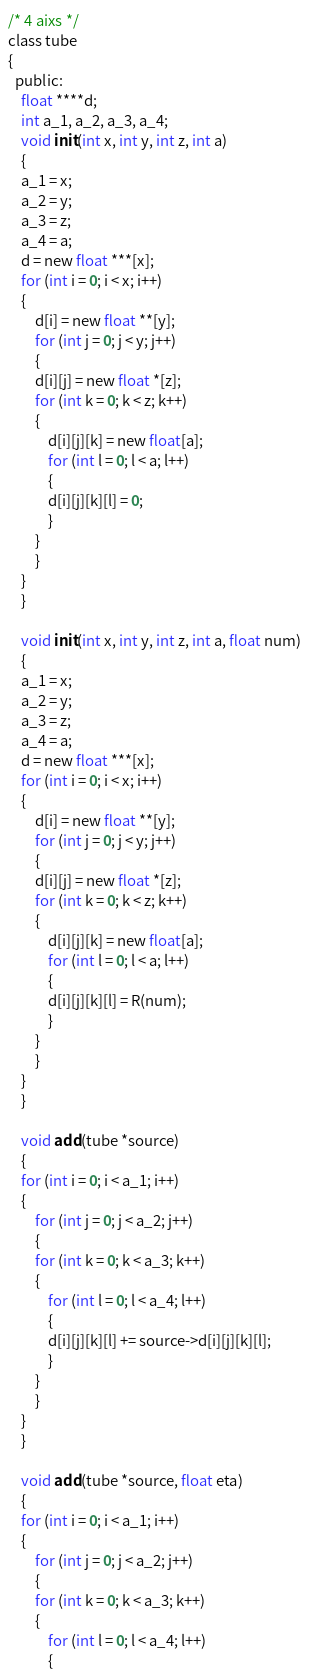<code> <loc_0><loc_0><loc_500><loc_500><_C_>/* 4 aixs */
class tube
{
  public:
    float ****d;
    int a_1, a_2, a_3, a_4;
    void init(int x, int y, int z, int a)
    {
	a_1 = x;
	a_2 = y;
	a_3 = z;
	a_4 = a;
	d = new float ***[x];
	for (int i = 0; i < x; i++)
	{
	    d[i] = new float **[y];
	    for (int j = 0; j < y; j++)
	    {
		d[i][j] = new float *[z];
		for (int k = 0; k < z; k++)
		{
		    d[i][j][k] = new float[a];
		    for (int l = 0; l < a; l++)
		    {
			d[i][j][k][l] = 0;
		    }
		}
	    }
	}
    }

    void init(int x, int y, int z, int a, float num)
    {
	a_1 = x;
	a_2 = y;
	a_3 = z;
	a_4 = a;
	d = new float ***[x];
	for (int i = 0; i < x; i++)
	{
	    d[i] = new float **[y];
	    for (int j = 0; j < y; j++)
	    {
		d[i][j] = new float *[z];
		for (int k = 0; k < z; k++)
		{
		    d[i][j][k] = new float[a];
		    for (int l = 0; l < a; l++)
		    {
			d[i][j][k][l] = R(num);
		    }
		}
	    }
	}
    }

    void add(tube *source)
    {
	for (int i = 0; i < a_1; i++)
	{
	    for (int j = 0; j < a_2; j++)
	    {
		for (int k = 0; k < a_3; k++)
		{
		    for (int l = 0; l < a_4; l++)
		    {
			d[i][j][k][l] += source->d[i][j][k][l];
		    }
		}
	    }
	}
    }

    void add(tube *source, float eta)
    {
	for (int i = 0; i < a_1; i++)
	{
	    for (int j = 0; j < a_2; j++)
	    {
		for (int k = 0; k < a_3; k++)
		{
		    for (int l = 0; l < a_4; l++)
		    {</code> 